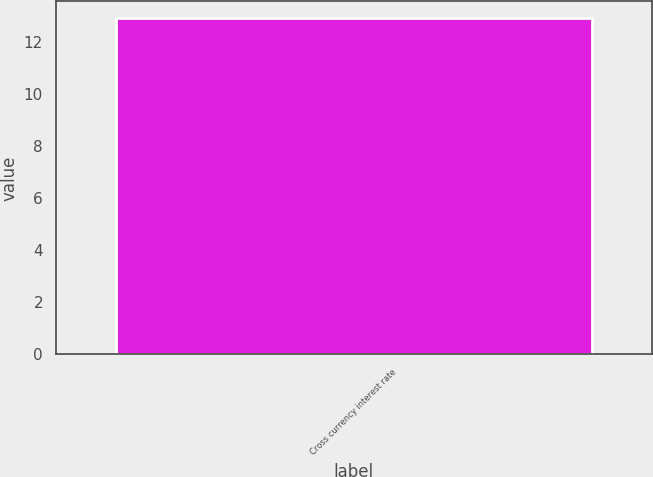Convert chart to OTSL. <chart><loc_0><loc_0><loc_500><loc_500><bar_chart><fcel>Cross currency interest rate<nl><fcel>12.9<nl></chart> 